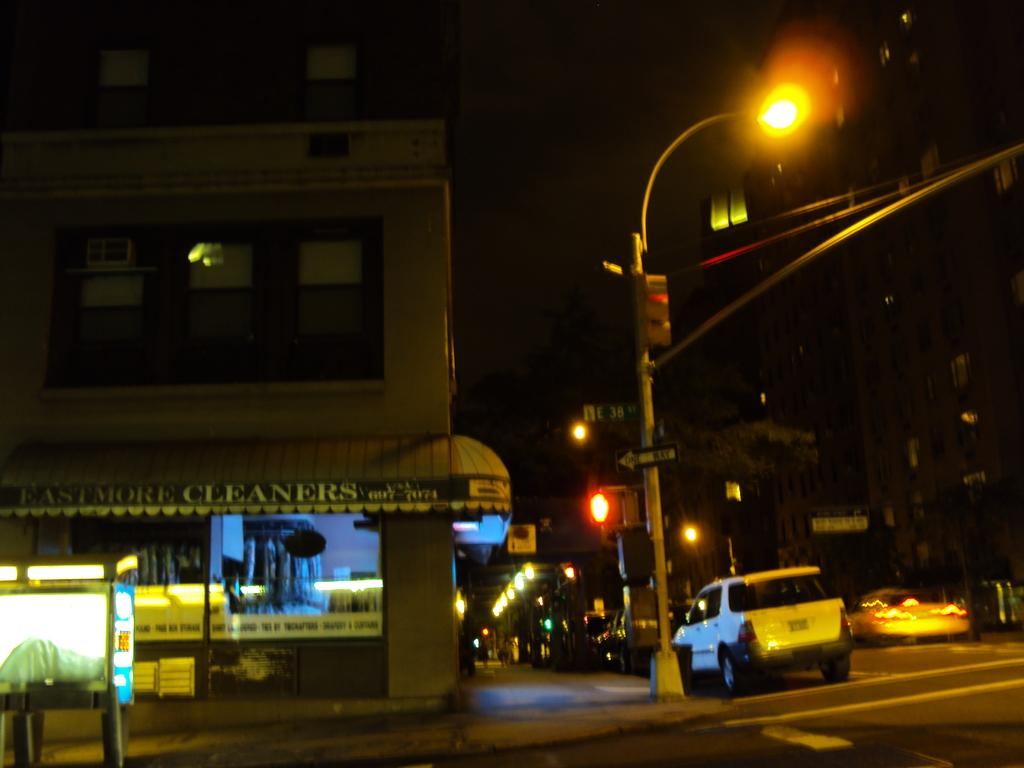<image>
Relay a brief, clear account of the picture shown. A street intersection with a cleaners place with green and white banner. 